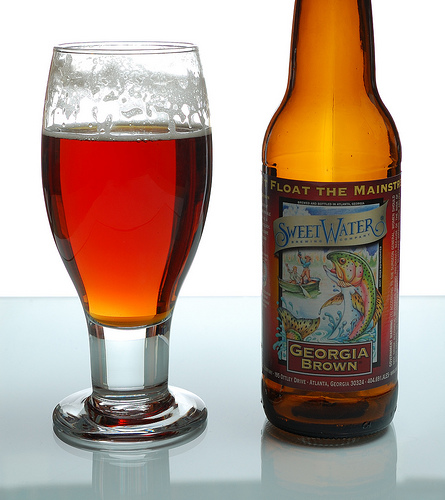<image>
Is the fish on the bottle? Yes. Looking at the image, I can see the fish is positioned on top of the bottle, with the bottle providing support. Where is the glass in relation to the bottle? Is it to the right of the bottle? Yes. From this viewpoint, the glass is positioned to the right side relative to the bottle. 